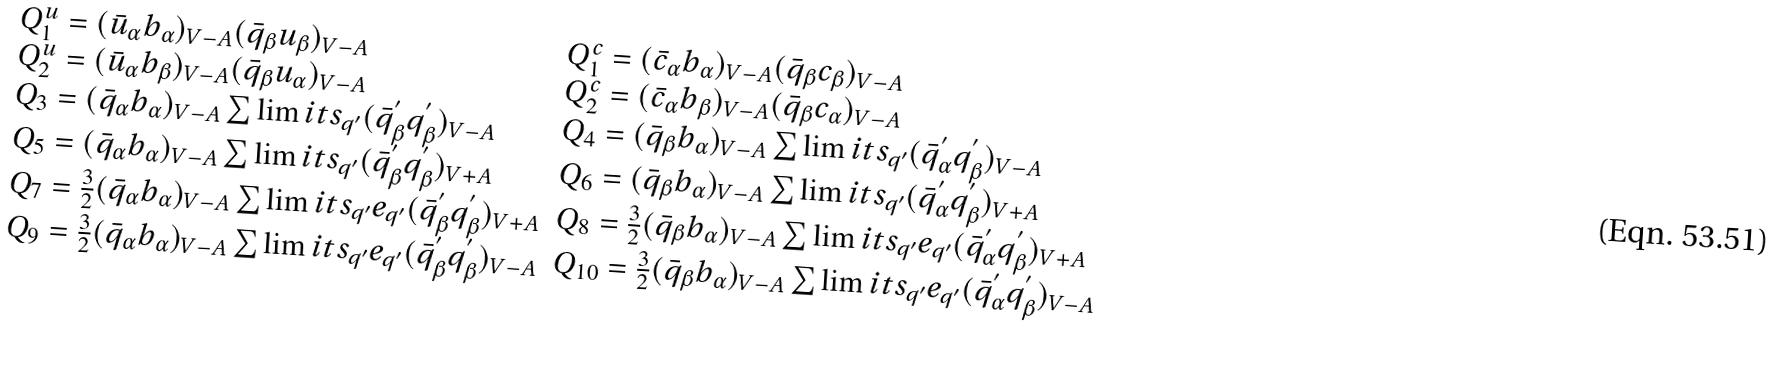<formula> <loc_0><loc_0><loc_500><loc_500>\begin{array} { l } \begin{array} { l l } Q ^ { u } _ { 1 } = ( \bar { u } _ { \alpha } b _ { \alpha } ) _ { V - A } ( \bar { q } _ { \beta } u _ { \beta } ) _ { V - A } & Q ^ { c } _ { 1 } = ( \bar { c } _ { \alpha } b _ { \alpha } ) _ { V - A } ( \bar { q } _ { \beta } c _ { \beta } ) _ { V - A } \\ Q ^ { u } _ { 2 } = ( \bar { u } _ { \alpha } b _ { \beta } ) _ { V - A } ( \bar { q } _ { \beta } u _ { \alpha } ) _ { V - A } & Q ^ { c } _ { 2 } = ( \bar { c } _ { \alpha } b _ { \beta } ) _ { V - A } ( \bar { q } _ { \beta } c _ { \alpha } ) _ { V - A } \\ Q _ { 3 } = ( \bar { q } _ { \alpha } b _ { \alpha } ) _ { V - A } \sum \lim i t s _ { q ^ { \prime } } ( \bar { q } ^ { ^ { \prime } } _ { \beta } q ^ { ^ { \prime } } _ { \beta } ) _ { V - A } & Q _ { 4 } = ( \bar { q } _ { \beta } b _ { \alpha } ) _ { V - A } \sum \lim i t s _ { q ^ { \prime } } ( \bar { q } ^ { ^ { \prime } } _ { \alpha } q ^ { ^ { \prime } } _ { \beta } ) _ { V - A } \\ Q _ { 5 } = ( \bar { q } _ { \alpha } b _ { \alpha } ) _ { V - A } \sum \lim i t s _ { q ^ { \prime } } ( \bar { q } ^ { ^ { \prime } } _ { \beta } q ^ { ^ { \prime } } _ { \beta } ) _ { V + A } & Q _ { 6 } = ( \bar { q } _ { \beta } b _ { \alpha } ) _ { V - A } \sum \lim i t s _ { q ^ { \prime } } ( \bar { q } ^ { ^ { \prime } } _ { \alpha } q ^ { ^ { \prime } } _ { \beta } ) _ { V + A } \\ Q _ { 7 } = \frac { 3 } { 2 } ( \bar { q } _ { \alpha } b _ { \alpha } ) _ { V - A } \sum \lim i t s _ { q ^ { \prime } } e _ { q ^ { \prime } } ( \bar { q } ^ { ^ { \prime } } _ { \beta } q ^ { ^ { \prime } } _ { \beta } ) _ { V + A } & Q _ { 8 } = \frac { 3 } { 2 } ( \bar { q } _ { \beta } b _ { \alpha } ) _ { V - A } \sum \lim i t s _ { q ^ { \prime } } e _ { q ^ { \prime } } ( \bar { q } ^ { ^ { \prime } } _ { \alpha } q ^ { ^ { \prime } } _ { \beta } ) _ { V + A } \\ Q _ { 9 } = \frac { 3 } { 2 } ( \bar { q } _ { \alpha } b _ { \alpha } ) _ { V - A } \sum \lim i t s _ { q ^ { \prime } } e _ { q ^ { \prime } } ( \bar { q } ^ { ^ { \prime } } _ { \beta } q ^ { ^ { \prime } } _ { \beta } ) _ { V - A } & Q _ { 1 0 } = \frac { 3 } { 2 } ( \bar { q } _ { \beta } b _ { \alpha } ) _ { V - A } \sum \lim i t s _ { q ^ { \prime } } e _ { q ^ { \prime } } ( \bar { q } ^ { ^ { \prime } } _ { \alpha } q ^ { ^ { \prime } } _ { \beta } ) _ { V - A } \\ \end{array} \\ \end{array}</formula> 